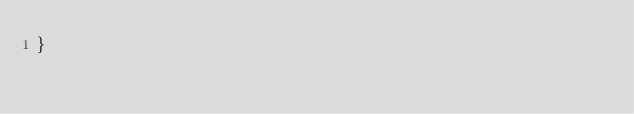Convert code to text. <code><loc_0><loc_0><loc_500><loc_500><_TypeScript_>}</code> 